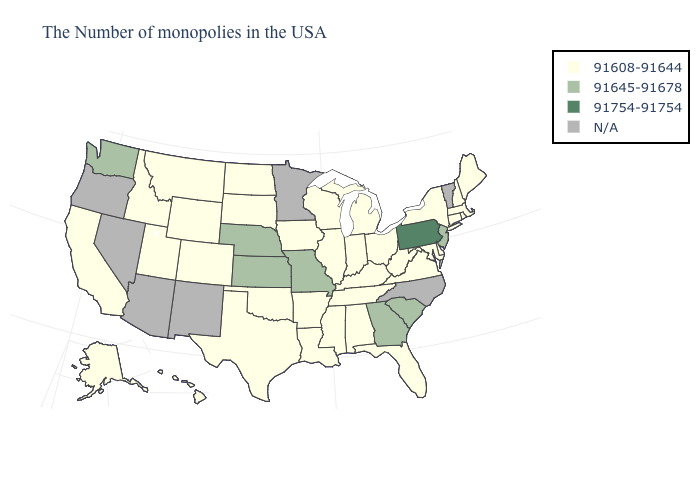Name the states that have a value in the range 91608-91644?
Give a very brief answer. Maine, Massachusetts, Rhode Island, New Hampshire, Connecticut, New York, Delaware, Maryland, Virginia, West Virginia, Ohio, Florida, Michigan, Kentucky, Indiana, Alabama, Tennessee, Wisconsin, Illinois, Mississippi, Louisiana, Arkansas, Iowa, Oklahoma, Texas, South Dakota, North Dakota, Wyoming, Colorado, Utah, Montana, Idaho, California, Alaska, Hawaii. What is the value of South Dakota?
Write a very short answer. 91608-91644. Name the states that have a value in the range 91754-91754?
Write a very short answer. Pennsylvania. Among the states that border South Dakota , which have the lowest value?
Write a very short answer. Iowa, North Dakota, Wyoming, Montana. What is the value of Minnesota?
Answer briefly. N/A. Which states hav the highest value in the MidWest?
Keep it brief. Missouri, Kansas, Nebraska. Which states have the lowest value in the West?
Give a very brief answer. Wyoming, Colorado, Utah, Montana, Idaho, California, Alaska, Hawaii. Name the states that have a value in the range 91754-91754?
Keep it brief. Pennsylvania. Name the states that have a value in the range N/A?
Concise answer only. Vermont, North Carolina, Minnesota, New Mexico, Arizona, Nevada, Oregon. Among the states that border Nebraska , does Wyoming have the lowest value?
Give a very brief answer. Yes. Does the map have missing data?
Give a very brief answer. Yes. How many symbols are there in the legend?
Be succinct. 4. Name the states that have a value in the range 91608-91644?
Write a very short answer. Maine, Massachusetts, Rhode Island, New Hampshire, Connecticut, New York, Delaware, Maryland, Virginia, West Virginia, Ohio, Florida, Michigan, Kentucky, Indiana, Alabama, Tennessee, Wisconsin, Illinois, Mississippi, Louisiana, Arkansas, Iowa, Oklahoma, Texas, South Dakota, North Dakota, Wyoming, Colorado, Utah, Montana, Idaho, California, Alaska, Hawaii. 